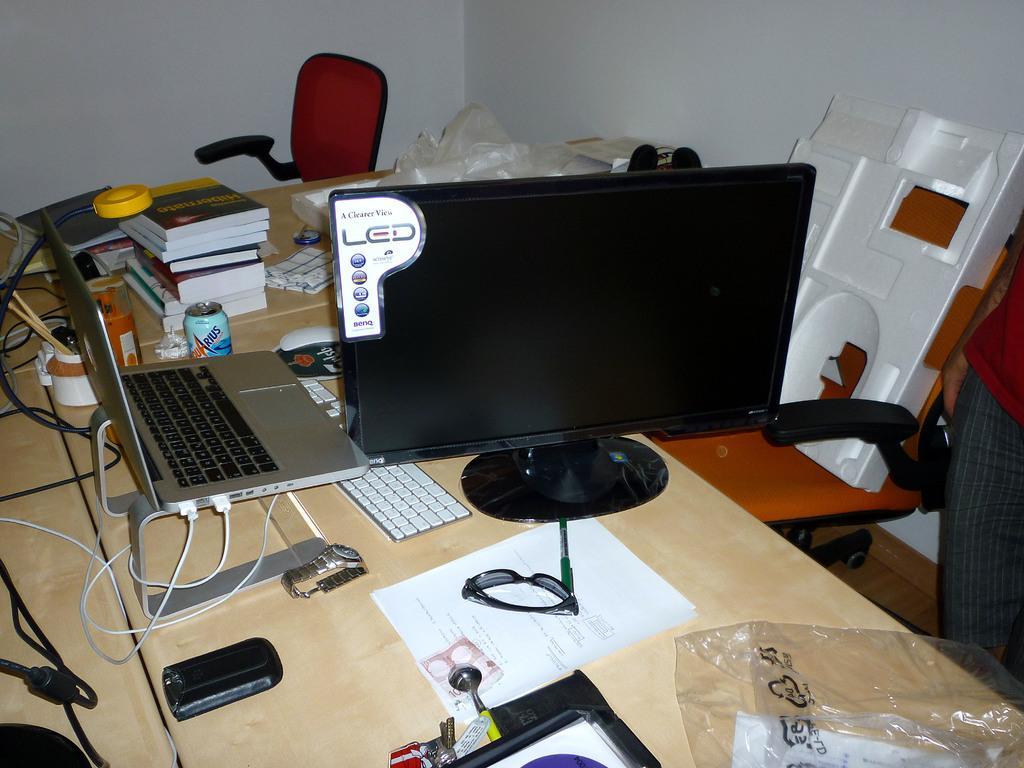Please provide a concise description of this image. In the above picture i could see the screen of the television with a stand and beside the television screen there is a laptop connected to some cables and there is a key board under this laptop and there is orange colored chair beside the table. Table is light brown color. Beside the laptop there is a watch and beside this TV there is paper and on the paper there are goggles, goggles and also some papers and spoons and near by paper there is a key chain with keys. On the table there are some books some tin and a holder holding some pens and some files beside the books, there is in back ground and in back ground there is chair red color chair, and i could see a wall in the picture in the top picture. 